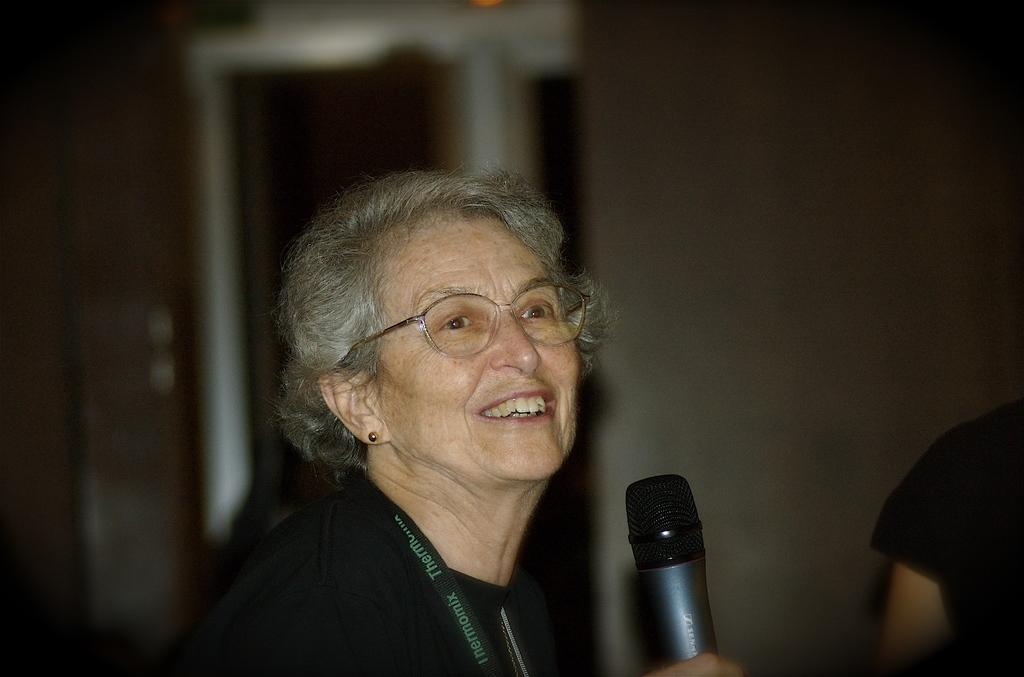Who is the main subject in the image? There is an old woman in the image. What is the old woman holding in the image? The old woman is holding a microphone. What is the expression on the old woman's face? The old woman has a smiling face. Can you describe the other person in the image? There is another person in the image, but their features are not clear due to the blurry background. What type of stick can be seen holding the microphone in the image? There is no stick present in the image; the old woman is holding the microphone directly with her hand. 